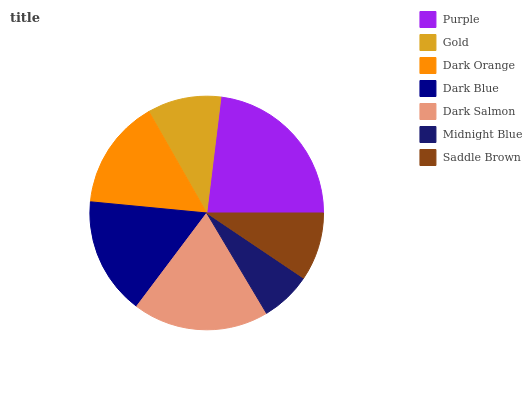Is Midnight Blue the minimum?
Answer yes or no. Yes. Is Purple the maximum?
Answer yes or no. Yes. Is Gold the minimum?
Answer yes or no. No. Is Gold the maximum?
Answer yes or no. No. Is Purple greater than Gold?
Answer yes or no. Yes. Is Gold less than Purple?
Answer yes or no. Yes. Is Gold greater than Purple?
Answer yes or no. No. Is Purple less than Gold?
Answer yes or no. No. Is Dark Orange the high median?
Answer yes or no. Yes. Is Dark Orange the low median?
Answer yes or no. Yes. Is Gold the high median?
Answer yes or no. No. Is Purple the low median?
Answer yes or no. No. 